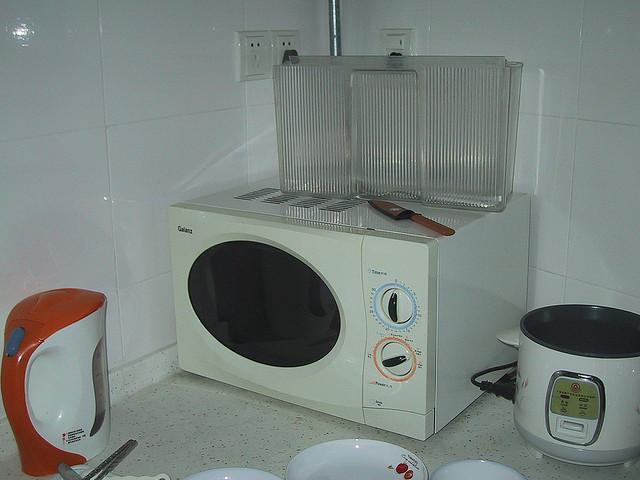Is the microwave on?
Keep it brief. No. Is this a laundry room?
Write a very short answer. No. What is the red and white thing?
Write a very short answer. Don't know. Is this microwave a model that is found commonly in the United States?
Short answer required. No. 